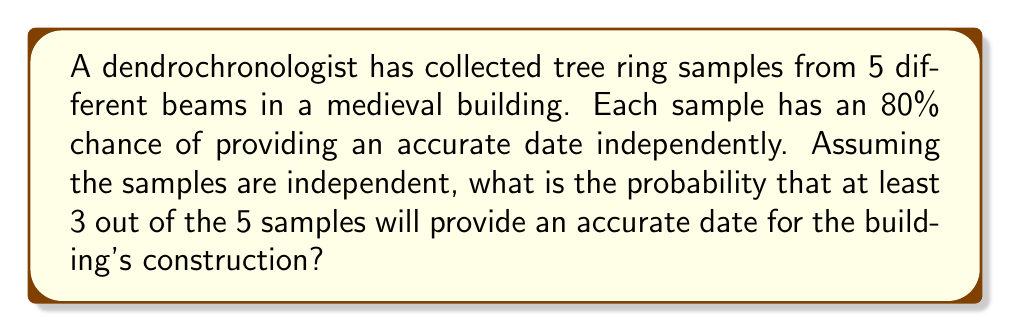Teach me how to tackle this problem. To solve this problem, we can use the binomial probability distribution.

Let's define:
$n = 5$ (total number of samples)
$p = 0.8$ (probability of an accurate date from a single sample)
$q = 1 - p = 0.2$ (probability of an inaccurate date)

We want to find the probability of at least 3 accurate dates, which means we need to sum the probabilities of getting 3, 4, or 5 accurate dates.

The binomial probability formula is:

$$P(X = k) = \binom{n}{k} p^k q^{n-k}$$

Where $\binom{n}{k}$ is the binomial coefficient.

Step 1: Calculate $P(X = 3)$
$$P(X = 3) = \binom{5}{3} (0.8)^3 (0.2)^2 = 10 \cdot 0.512 \cdot 0.04 = 0.2048$$

Step 2: Calculate $P(X = 4)$
$$P(X = 4) = \binom{5}{4} (0.8)^4 (0.2)^1 = 5 \cdot 0.4096 \cdot 0.2 = 0.4096$$

Step 3: Calculate $P(X = 5)$
$$P(X = 5) = \binom{5}{5} (0.8)^5 (0.2)^0 = 1 \cdot 0.32768 \cdot 1 = 0.32768$$

Step 4: Sum the probabilities
$$P(X \geq 3) = P(X = 3) + P(X = 4) + P(X = 5)$$
$$P(X \geq 3) = 0.2048 + 0.4096 + 0.32768 = 0.94208$$

Therefore, the probability of at least 3 out of 5 samples providing an accurate date is approximately 0.94208 or 94.208%.
Answer: 0.94208 